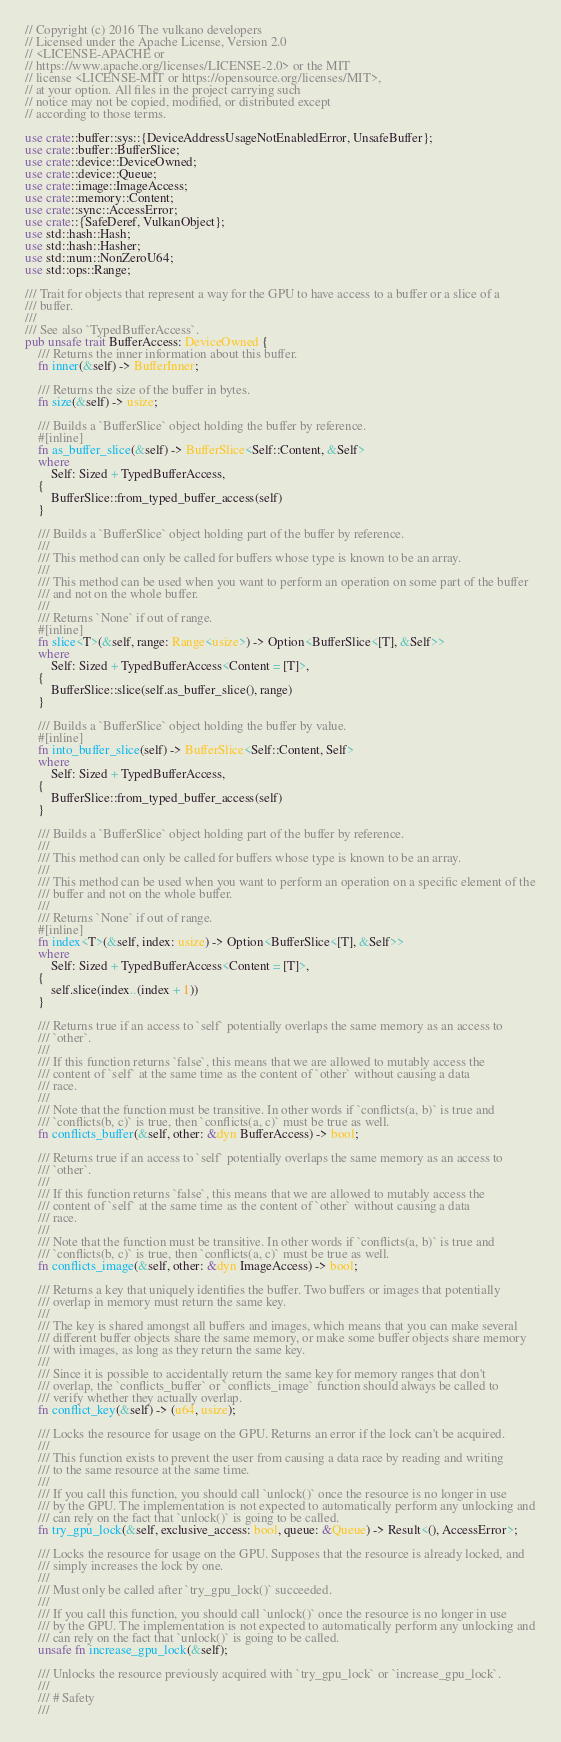Convert code to text. <code><loc_0><loc_0><loc_500><loc_500><_Rust_>// Copyright (c) 2016 The vulkano developers
// Licensed under the Apache License, Version 2.0
// <LICENSE-APACHE or
// https://www.apache.org/licenses/LICENSE-2.0> or the MIT
// license <LICENSE-MIT or https://opensource.org/licenses/MIT>,
// at your option. All files in the project carrying such
// notice may not be copied, modified, or distributed except
// according to those terms.

use crate::buffer::sys::{DeviceAddressUsageNotEnabledError, UnsafeBuffer};
use crate::buffer::BufferSlice;
use crate::device::DeviceOwned;
use crate::device::Queue;
use crate::image::ImageAccess;
use crate::memory::Content;
use crate::sync::AccessError;
use crate::{SafeDeref, VulkanObject};
use std::hash::Hash;
use std::hash::Hasher;
use std::num::NonZeroU64;
use std::ops::Range;

/// Trait for objects that represent a way for the GPU to have access to a buffer or a slice of a
/// buffer.
///
/// See also `TypedBufferAccess`.
pub unsafe trait BufferAccess: DeviceOwned {
    /// Returns the inner information about this buffer.
    fn inner(&self) -> BufferInner;

    /// Returns the size of the buffer in bytes.
    fn size(&self) -> usize;

    /// Builds a `BufferSlice` object holding the buffer by reference.
    #[inline]
    fn as_buffer_slice(&self) -> BufferSlice<Self::Content, &Self>
    where
        Self: Sized + TypedBufferAccess,
    {
        BufferSlice::from_typed_buffer_access(self)
    }

    /// Builds a `BufferSlice` object holding part of the buffer by reference.
    ///
    /// This method can only be called for buffers whose type is known to be an array.
    ///
    /// This method can be used when you want to perform an operation on some part of the buffer
    /// and not on the whole buffer.
    ///
    /// Returns `None` if out of range.
    #[inline]
    fn slice<T>(&self, range: Range<usize>) -> Option<BufferSlice<[T], &Self>>
    where
        Self: Sized + TypedBufferAccess<Content = [T]>,
    {
        BufferSlice::slice(self.as_buffer_slice(), range)
    }

    /// Builds a `BufferSlice` object holding the buffer by value.
    #[inline]
    fn into_buffer_slice(self) -> BufferSlice<Self::Content, Self>
    where
        Self: Sized + TypedBufferAccess,
    {
        BufferSlice::from_typed_buffer_access(self)
    }

    /// Builds a `BufferSlice` object holding part of the buffer by reference.
    ///
    /// This method can only be called for buffers whose type is known to be an array.
    ///
    /// This method can be used when you want to perform an operation on a specific element of the
    /// buffer and not on the whole buffer.
    ///
    /// Returns `None` if out of range.
    #[inline]
    fn index<T>(&self, index: usize) -> Option<BufferSlice<[T], &Self>>
    where
        Self: Sized + TypedBufferAccess<Content = [T]>,
    {
        self.slice(index..(index + 1))
    }

    /// Returns true if an access to `self` potentially overlaps the same memory as an access to
    /// `other`.
    ///
    /// If this function returns `false`, this means that we are allowed to mutably access the
    /// content of `self` at the same time as the content of `other` without causing a data
    /// race.
    ///
    /// Note that the function must be transitive. In other words if `conflicts(a, b)` is true and
    /// `conflicts(b, c)` is true, then `conflicts(a, c)` must be true as well.
    fn conflicts_buffer(&self, other: &dyn BufferAccess) -> bool;

    /// Returns true if an access to `self` potentially overlaps the same memory as an access to
    /// `other`.
    ///
    /// If this function returns `false`, this means that we are allowed to mutably access the
    /// content of `self` at the same time as the content of `other` without causing a data
    /// race.
    ///
    /// Note that the function must be transitive. In other words if `conflicts(a, b)` is true and
    /// `conflicts(b, c)` is true, then `conflicts(a, c)` must be true as well.
    fn conflicts_image(&self, other: &dyn ImageAccess) -> bool;

    /// Returns a key that uniquely identifies the buffer. Two buffers or images that potentially
    /// overlap in memory must return the same key.
    ///
    /// The key is shared amongst all buffers and images, which means that you can make several
    /// different buffer objects share the same memory, or make some buffer objects share memory
    /// with images, as long as they return the same key.
    ///
    /// Since it is possible to accidentally return the same key for memory ranges that don't
    /// overlap, the `conflicts_buffer` or `conflicts_image` function should always be called to
    /// verify whether they actually overlap.
    fn conflict_key(&self) -> (u64, usize);

    /// Locks the resource for usage on the GPU. Returns an error if the lock can't be acquired.
    ///
    /// This function exists to prevent the user from causing a data race by reading and writing
    /// to the same resource at the same time.
    ///
    /// If you call this function, you should call `unlock()` once the resource is no longer in use
    /// by the GPU. The implementation is not expected to automatically perform any unlocking and
    /// can rely on the fact that `unlock()` is going to be called.
    fn try_gpu_lock(&self, exclusive_access: bool, queue: &Queue) -> Result<(), AccessError>;

    /// Locks the resource for usage on the GPU. Supposes that the resource is already locked, and
    /// simply increases the lock by one.
    ///
    /// Must only be called after `try_gpu_lock()` succeeded.
    ///
    /// If you call this function, you should call `unlock()` once the resource is no longer in use
    /// by the GPU. The implementation is not expected to automatically perform any unlocking and
    /// can rely on the fact that `unlock()` is going to be called.
    unsafe fn increase_gpu_lock(&self);

    /// Unlocks the resource previously acquired with `try_gpu_lock` or `increase_gpu_lock`.
    ///
    /// # Safety
    ///</code> 